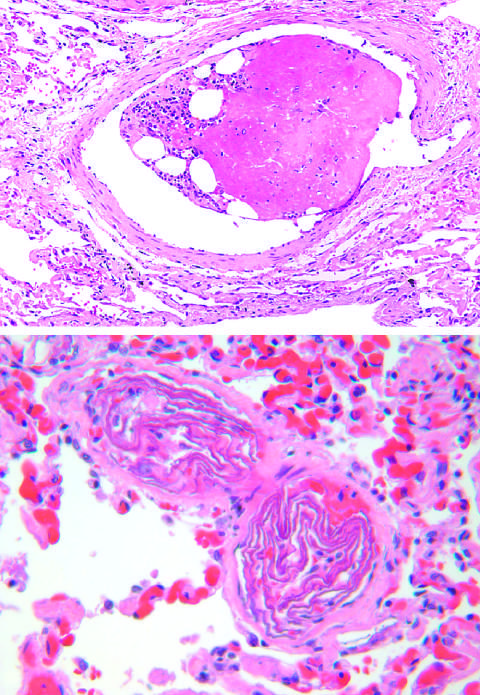s the surrounding lung edematous and congested?
Answer the question using a single word or phrase. Yes 